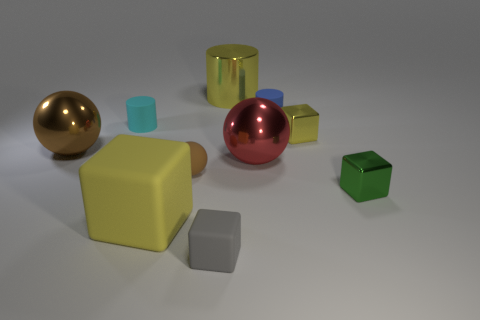Subtract all small cylinders. How many cylinders are left? 1 Subtract all cyan cylinders. How many cylinders are left? 2 Subtract 2 cubes. How many cubes are left? 2 Add 6 tiny yellow metal spheres. How many tiny yellow metal spheres exist? 6 Subtract 0 purple spheres. How many objects are left? 10 Subtract all spheres. How many objects are left? 7 Subtract all red spheres. Subtract all red cubes. How many spheres are left? 2 Subtract all brown cubes. How many red cylinders are left? 0 Subtract all tiny brown rubber balls. Subtract all shiny objects. How many objects are left? 4 Add 3 gray matte objects. How many gray matte objects are left? 4 